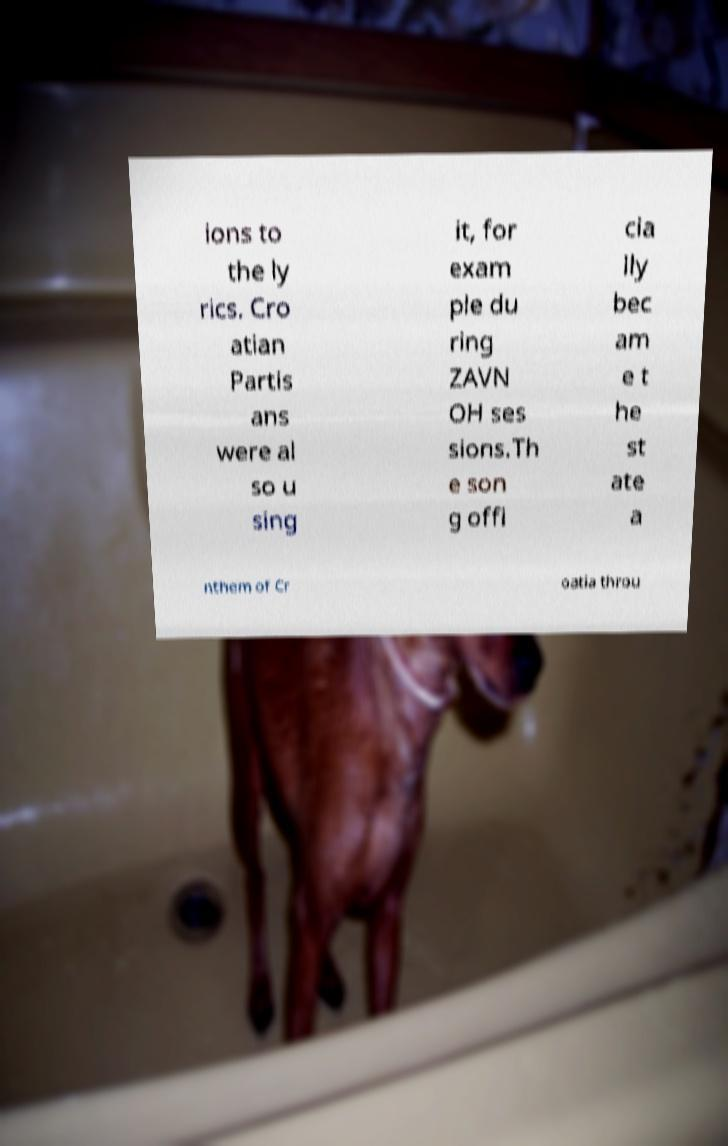Could you assist in decoding the text presented in this image and type it out clearly? ions to the ly rics. Cro atian Partis ans were al so u sing it, for exam ple du ring ZAVN OH ses sions.Th e son g offi cia lly bec am e t he st ate a nthem of Cr oatia throu 